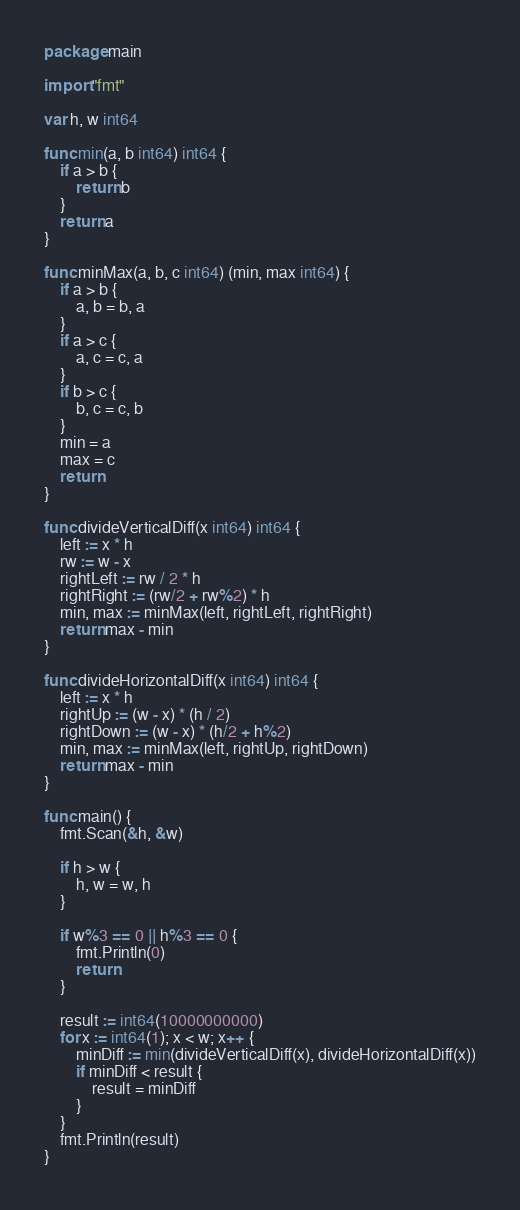<code> <loc_0><loc_0><loc_500><loc_500><_Go_>package main

import "fmt"

var h, w int64

func min(a, b int64) int64 {
	if a > b {
		return b
	}
	return a
}

func minMax(a, b, c int64) (min, max int64) {
	if a > b {
		a, b = b, a
	}
	if a > c {
		a, c = c, a
	}
	if b > c {
		b, c = c, b
	}
	min = a
	max = c
	return
}

func divideVerticalDiff(x int64) int64 {
	left := x * h
	rw := w - x
	rightLeft := rw / 2 * h
	rightRight := (rw/2 + rw%2) * h
	min, max := minMax(left, rightLeft, rightRight)
	return max - min
}

func divideHorizontalDiff(x int64) int64 {
	left := x * h
	rightUp := (w - x) * (h / 2)
	rightDown := (w - x) * (h/2 + h%2)
	min, max := minMax(left, rightUp, rightDown)
	return max - min
}

func main() {
	fmt.Scan(&h, &w)

	if h > w {
		h, w = w, h
	}

	if w%3 == 0 || h%3 == 0 {
		fmt.Println(0)
		return
	}

	result := int64(10000000000)
	for x := int64(1); x < w; x++ {
		minDiff := min(divideVerticalDiff(x), divideHorizontalDiff(x))
		if minDiff < result {
			result = minDiff
		}
	}
	fmt.Println(result)
}</code> 